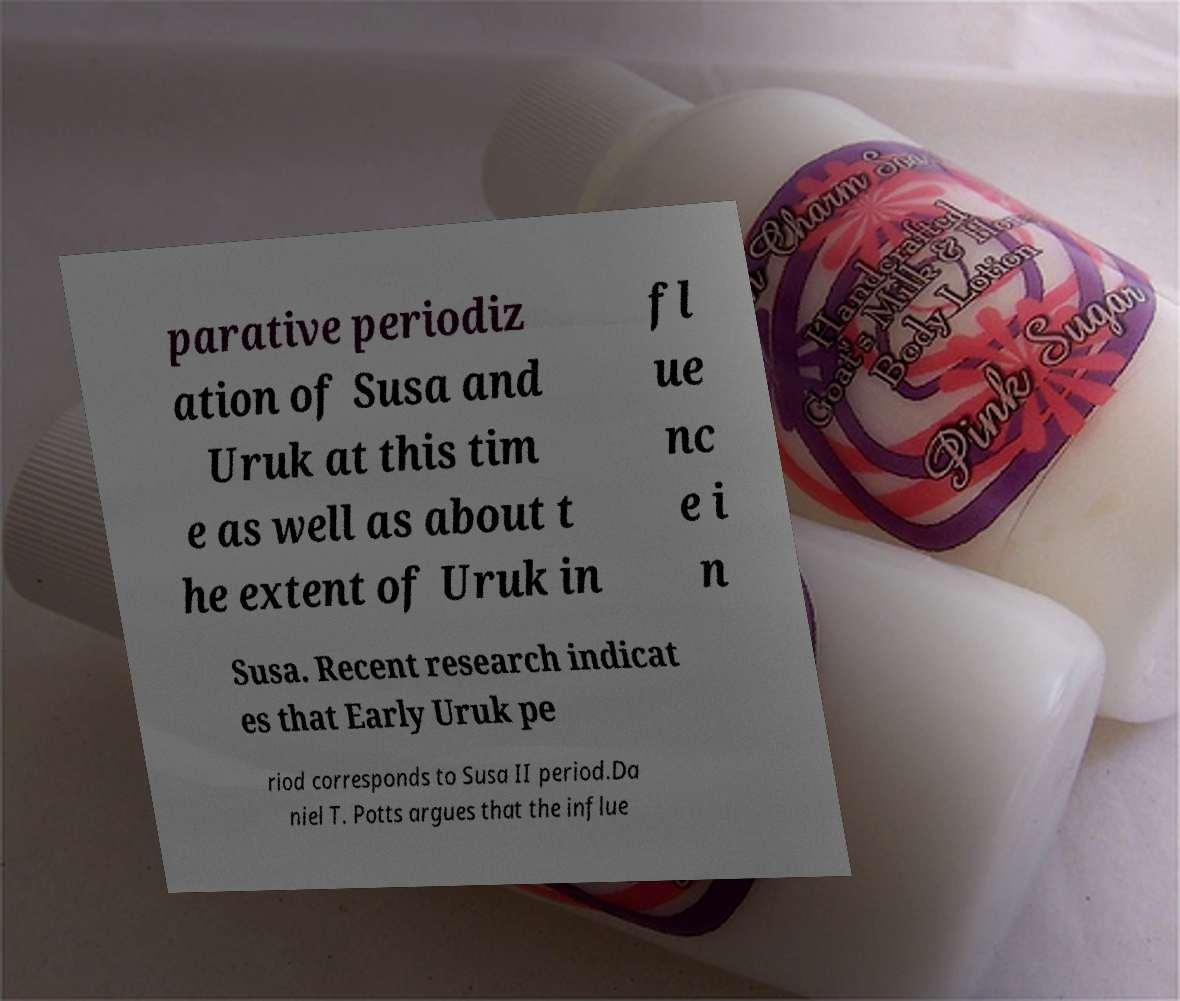For documentation purposes, I need the text within this image transcribed. Could you provide that? parative periodiz ation of Susa and Uruk at this tim e as well as about t he extent of Uruk in fl ue nc e i n Susa. Recent research indicat es that Early Uruk pe riod corresponds to Susa II period.Da niel T. Potts argues that the influe 